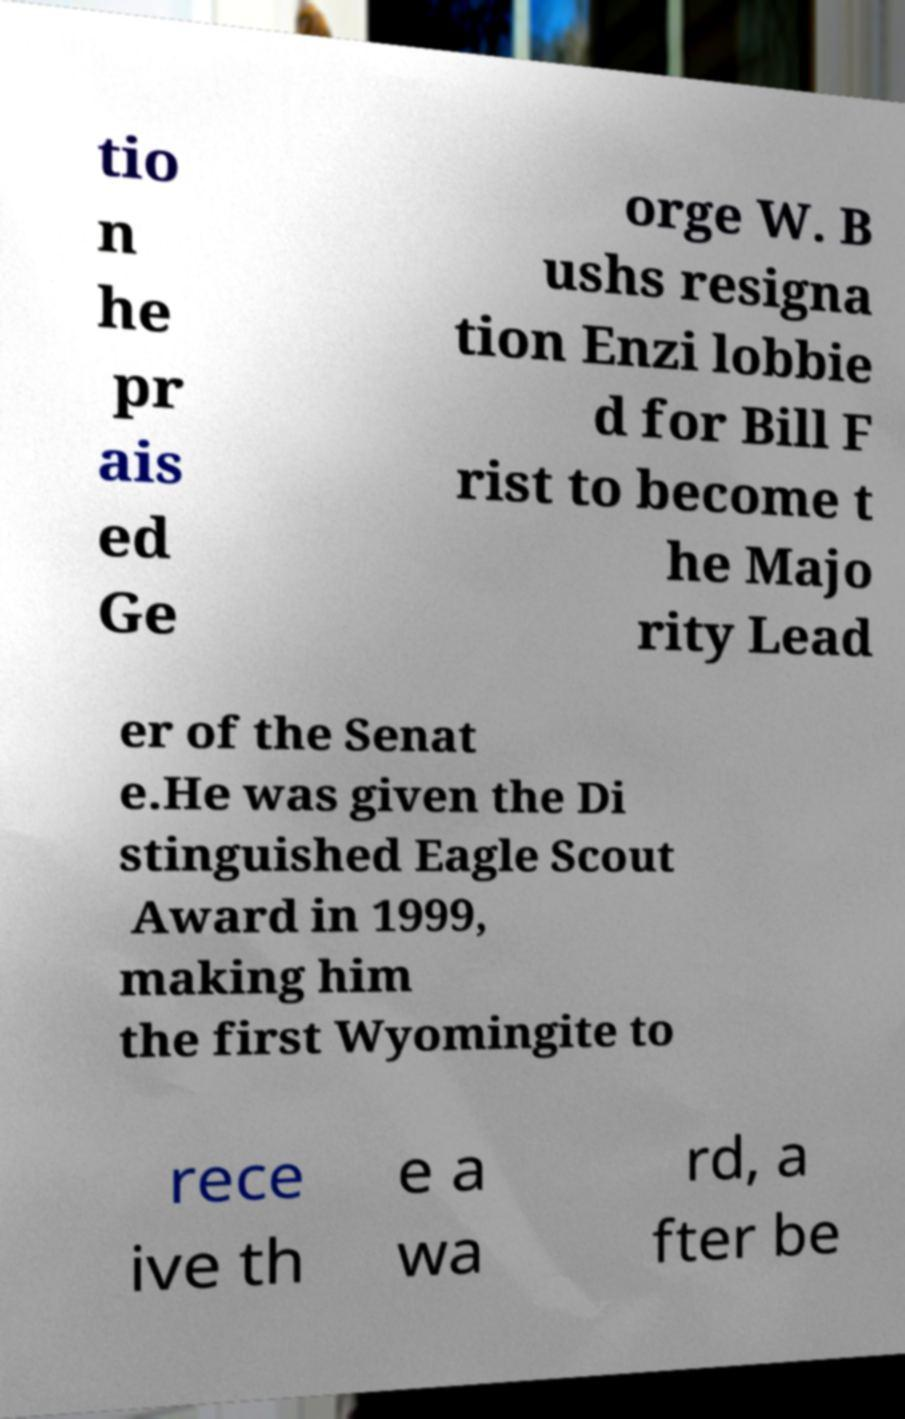Please read and relay the text visible in this image. What does it say? tio n he pr ais ed Ge orge W. B ushs resigna tion Enzi lobbie d for Bill F rist to become t he Majo rity Lead er of the Senat e.He was given the Di stinguished Eagle Scout Award in 1999, making him the first Wyomingite to rece ive th e a wa rd, a fter be 